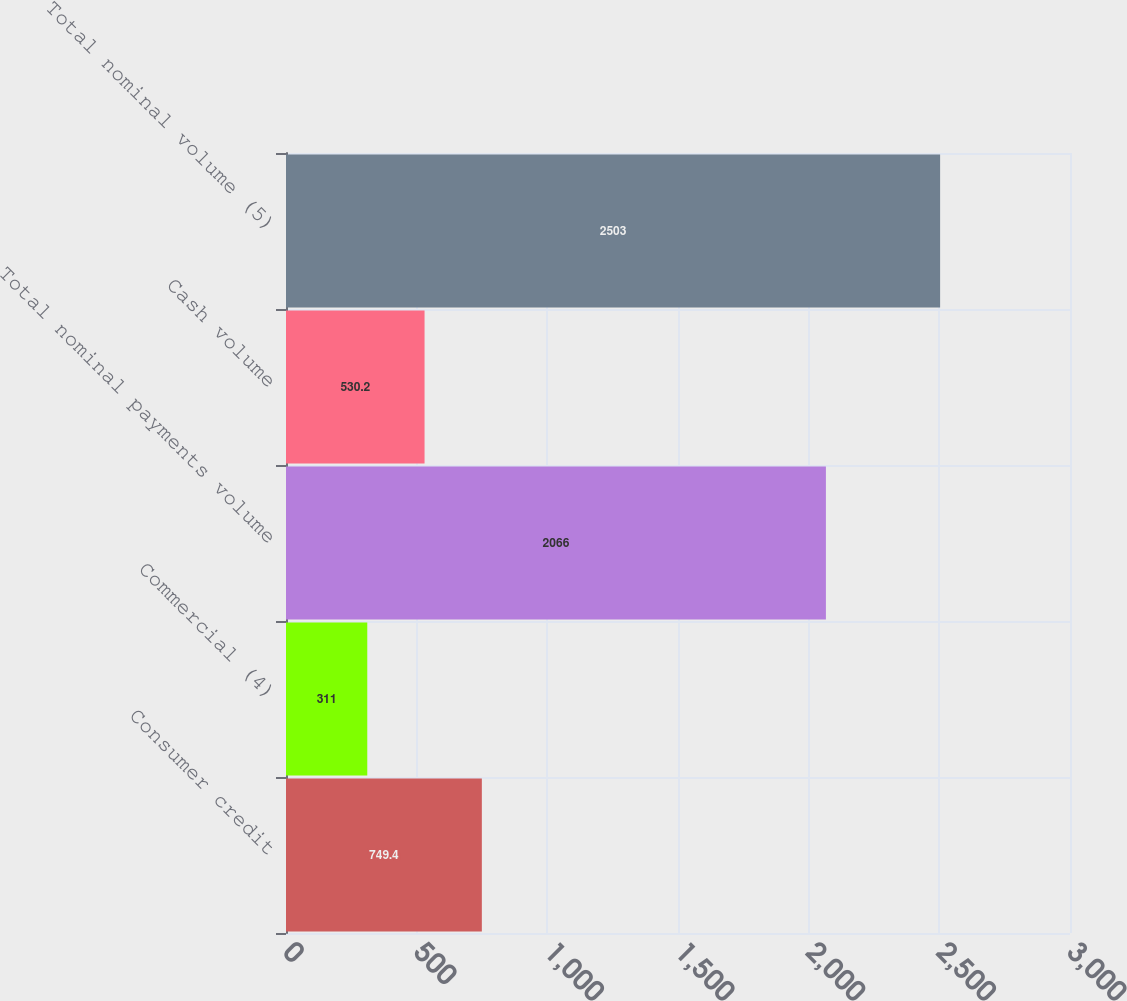Convert chart. <chart><loc_0><loc_0><loc_500><loc_500><bar_chart><fcel>Consumer credit<fcel>Commercial (4)<fcel>Total nominal payments volume<fcel>Cash volume<fcel>Total nominal volume (5)<nl><fcel>749.4<fcel>311<fcel>2066<fcel>530.2<fcel>2503<nl></chart> 